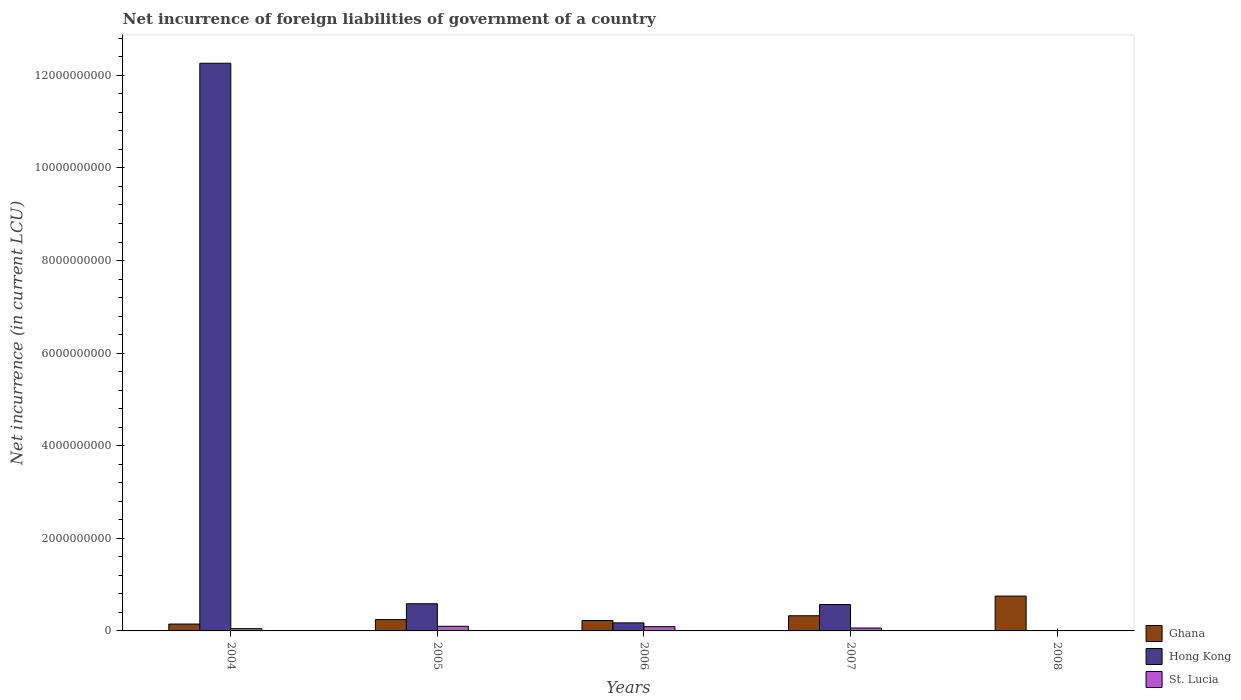Are the number of bars per tick equal to the number of legend labels?
Provide a succinct answer. No. Are the number of bars on each tick of the X-axis equal?
Provide a short and direct response. No. How many bars are there on the 4th tick from the left?
Provide a succinct answer. 3. What is the label of the 1st group of bars from the left?
Your answer should be compact. 2004. What is the net incurrence of foreign liabilities in Ghana in 2008?
Ensure brevity in your answer.  7.53e+08. Across all years, what is the maximum net incurrence of foreign liabilities in St. Lucia?
Offer a terse response. 9.99e+07. Across all years, what is the minimum net incurrence of foreign liabilities in St. Lucia?
Provide a short and direct response. 0. In which year was the net incurrence of foreign liabilities in St. Lucia maximum?
Offer a very short reply. 2005. What is the total net incurrence of foreign liabilities in Ghana in the graph?
Give a very brief answer. 1.70e+09. What is the difference between the net incurrence of foreign liabilities in Hong Kong in 2005 and that in 2006?
Keep it short and to the point. 4.13e+08. What is the difference between the net incurrence of foreign liabilities in Ghana in 2007 and the net incurrence of foreign liabilities in St. Lucia in 2005?
Provide a short and direct response. 2.27e+08. What is the average net incurrence of foreign liabilities in Ghana per year?
Your response must be concise. 3.40e+08. In the year 2006, what is the difference between the net incurrence of foreign liabilities in Hong Kong and net incurrence of foreign liabilities in St. Lucia?
Provide a short and direct response. 8.17e+07. In how many years, is the net incurrence of foreign liabilities in St. Lucia greater than 5200000000 LCU?
Keep it short and to the point. 0. What is the ratio of the net incurrence of foreign liabilities in Ghana in 2005 to that in 2007?
Your response must be concise. 0.75. Is the difference between the net incurrence of foreign liabilities in Hong Kong in 2006 and 2007 greater than the difference between the net incurrence of foreign liabilities in St. Lucia in 2006 and 2007?
Keep it short and to the point. No. What is the difference between the highest and the second highest net incurrence of foreign liabilities in St. Lucia?
Keep it short and to the point. 7.60e+06. What is the difference between the highest and the lowest net incurrence of foreign liabilities in St. Lucia?
Offer a very short reply. 9.99e+07. How many bars are there?
Make the answer very short. 13. Are all the bars in the graph horizontal?
Make the answer very short. No. Are the values on the major ticks of Y-axis written in scientific E-notation?
Make the answer very short. No. Does the graph contain any zero values?
Offer a very short reply. Yes. What is the title of the graph?
Your answer should be compact. Net incurrence of foreign liabilities of government of a country. What is the label or title of the X-axis?
Your response must be concise. Years. What is the label or title of the Y-axis?
Offer a terse response. Net incurrence (in current LCU). What is the Net incurrence (in current LCU) of Ghana in 2004?
Make the answer very short. 1.49e+08. What is the Net incurrence (in current LCU) of Hong Kong in 2004?
Offer a very short reply. 1.23e+1. What is the Net incurrence (in current LCU) in St. Lucia in 2004?
Offer a terse response. 4.89e+07. What is the Net incurrence (in current LCU) in Ghana in 2005?
Make the answer very short. 2.45e+08. What is the Net incurrence (in current LCU) in Hong Kong in 2005?
Provide a short and direct response. 5.87e+08. What is the Net incurrence (in current LCU) in St. Lucia in 2005?
Give a very brief answer. 9.99e+07. What is the Net incurrence (in current LCU) in Ghana in 2006?
Provide a succinct answer. 2.25e+08. What is the Net incurrence (in current LCU) of Hong Kong in 2006?
Make the answer very short. 1.74e+08. What is the Net incurrence (in current LCU) of St. Lucia in 2006?
Your answer should be very brief. 9.23e+07. What is the Net incurrence (in current LCU) of Ghana in 2007?
Keep it short and to the point. 3.27e+08. What is the Net incurrence (in current LCU) of Hong Kong in 2007?
Your answer should be very brief. 5.70e+08. What is the Net incurrence (in current LCU) in St. Lucia in 2007?
Your answer should be compact. 6.28e+07. What is the Net incurrence (in current LCU) of Ghana in 2008?
Offer a very short reply. 7.53e+08. Across all years, what is the maximum Net incurrence (in current LCU) in Ghana?
Offer a very short reply. 7.53e+08. Across all years, what is the maximum Net incurrence (in current LCU) in Hong Kong?
Your answer should be very brief. 1.23e+1. Across all years, what is the maximum Net incurrence (in current LCU) of St. Lucia?
Provide a short and direct response. 9.99e+07. Across all years, what is the minimum Net incurrence (in current LCU) in Ghana?
Provide a short and direct response. 1.49e+08. What is the total Net incurrence (in current LCU) in Ghana in the graph?
Provide a succinct answer. 1.70e+09. What is the total Net incurrence (in current LCU) of Hong Kong in the graph?
Your answer should be very brief. 1.36e+1. What is the total Net incurrence (in current LCU) in St. Lucia in the graph?
Offer a very short reply. 3.04e+08. What is the difference between the Net incurrence (in current LCU) in Ghana in 2004 and that in 2005?
Keep it short and to the point. -9.61e+07. What is the difference between the Net incurrence (in current LCU) in Hong Kong in 2004 and that in 2005?
Your response must be concise. 1.17e+1. What is the difference between the Net incurrence (in current LCU) in St. Lucia in 2004 and that in 2005?
Your answer should be very brief. -5.10e+07. What is the difference between the Net incurrence (in current LCU) of Ghana in 2004 and that in 2006?
Your answer should be very brief. -7.64e+07. What is the difference between the Net incurrence (in current LCU) of Hong Kong in 2004 and that in 2006?
Provide a short and direct response. 1.21e+1. What is the difference between the Net incurrence (in current LCU) in St. Lucia in 2004 and that in 2006?
Provide a short and direct response. -4.34e+07. What is the difference between the Net incurrence (in current LCU) of Ghana in 2004 and that in 2007?
Ensure brevity in your answer.  -1.79e+08. What is the difference between the Net incurrence (in current LCU) in Hong Kong in 2004 and that in 2007?
Make the answer very short. 1.17e+1. What is the difference between the Net incurrence (in current LCU) of St. Lucia in 2004 and that in 2007?
Give a very brief answer. -1.39e+07. What is the difference between the Net incurrence (in current LCU) of Ghana in 2004 and that in 2008?
Offer a very short reply. -6.04e+08. What is the difference between the Net incurrence (in current LCU) in Ghana in 2005 and that in 2006?
Offer a terse response. 1.97e+07. What is the difference between the Net incurrence (in current LCU) of Hong Kong in 2005 and that in 2006?
Offer a terse response. 4.13e+08. What is the difference between the Net incurrence (in current LCU) in St. Lucia in 2005 and that in 2006?
Your answer should be very brief. 7.60e+06. What is the difference between the Net incurrence (in current LCU) of Ghana in 2005 and that in 2007?
Keep it short and to the point. -8.27e+07. What is the difference between the Net incurrence (in current LCU) of Hong Kong in 2005 and that in 2007?
Make the answer very short. 1.70e+07. What is the difference between the Net incurrence (in current LCU) of St. Lucia in 2005 and that in 2007?
Ensure brevity in your answer.  3.71e+07. What is the difference between the Net incurrence (in current LCU) in Ghana in 2005 and that in 2008?
Your answer should be compact. -5.08e+08. What is the difference between the Net incurrence (in current LCU) in Ghana in 2006 and that in 2007?
Ensure brevity in your answer.  -1.02e+08. What is the difference between the Net incurrence (in current LCU) of Hong Kong in 2006 and that in 2007?
Your answer should be compact. -3.96e+08. What is the difference between the Net incurrence (in current LCU) of St. Lucia in 2006 and that in 2007?
Keep it short and to the point. 2.95e+07. What is the difference between the Net incurrence (in current LCU) in Ghana in 2006 and that in 2008?
Your response must be concise. -5.28e+08. What is the difference between the Net incurrence (in current LCU) of Ghana in 2007 and that in 2008?
Provide a short and direct response. -4.25e+08. What is the difference between the Net incurrence (in current LCU) of Ghana in 2004 and the Net incurrence (in current LCU) of Hong Kong in 2005?
Provide a short and direct response. -4.38e+08. What is the difference between the Net incurrence (in current LCU) of Ghana in 2004 and the Net incurrence (in current LCU) of St. Lucia in 2005?
Keep it short and to the point. 4.87e+07. What is the difference between the Net incurrence (in current LCU) in Hong Kong in 2004 and the Net incurrence (in current LCU) in St. Lucia in 2005?
Your response must be concise. 1.22e+1. What is the difference between the Net incurrence (in current LCU) in Ghana in 2004 and the Net incurrence (in current LCU) in Hong Kong in 2006?
Offer a very short reply. -2.54e+07. What is the difference between the Net incurrence (in current LCU) of Ghana in 2004 and the Net incurrence (in current LCU) of St. Lucia in 2006?
Offer a terse response. 5.63e+07. What is the difference between the Net incurrence (in current LCU) in Hong Kong in 2004 and the Net incurrence (in current LCU) in St. Lucia in 2006?
Your response must be concise. 1.22e+1. What is the difference between the Net incurrence (in current LCU) in Ghana in 2004 and the Net incurrence (in current LCU) in Hong Kong in 2007?
Keep it short and to the point. -4.21e+08. What is the difference between the Net incurrence (in current LCU) of Ghana in 2004 and the Net incurrence (in current LCU) of St. Lucia in 2007?
Your answer should be very brief. 8.58e+07. What is the difference between the Net incurrence (in current LCU) in Hong Kong in 2004 and the Net incurrence (in current LCU) in St. Lucia in 2007?
Your answer should be compact. 1.22e+1. What is the difference between the Net incurrence (in current LCU) in Ghana in 2005 and the Net incurrence (in current LCU) in Hong Kong in 2006?
Ensure brevity in your answer.  7.06e+07. What is the difference between the Net incurrence (in current LCU) of Ghana in 2005 and the Net incurrence (in current LCU) of St. Lucia in 2006?
Your response must be concise. 1.52e+08. What is the difference between the Net incurrence (in current LCU) in Hong Kong in 2005 and the Net incurrence (in current LCU) in St. Lucia in 2006?
Give a very brief answer. 4.95e+08. What is the difference between the Net incurrence (in current LCU) of Ghana in 2005 and the Net incurrence (in current LCU) of Hong Kong in 2007?
Your answer should be compact. -3.25e+08. What is the difference between the Net incurrence (in current LCU) of Ghana in 2005 and the Net incurrence (in current LCU) of St. Lucia in 2007?
Your answer should be very brief. 1.82e+08. What is the difference between the Net incurrence (in current LCU) in Hong Kong in 2005 and the Net incurrence (in current LCU) in St. Lucia in 2007?
Provide a short and direct response. 5.24e+08. What is the difference between the Net incurrence (in current LCU) in Ghana in 2006 and the Net incurrence (in current LCU) in Hong Kong in 2007?
Your answer should be compact. -3.45e+08. What is the difference between the Net incurrence (in current LCU) in Ghana in 2006 and the Net incurrence (in current LCU) in St. Lucia in 2007?
Provide a succinct answer. 1.62e+08. What is the difference between the Net incurrence (in current LCU) of Hong Kong in 2006 and the Net incurrence (in current LCU) of St. Lucia in 2007?
Offer a terse response. 1.11e+08. What is the average Net incurrence (in current LCU) in Ghana per year?
Your answer should be compact. 3.40e+08. What is the average Net incurrence (in current LCU) in Hong Kong per year?
Offer a very short reply. 2.72e+09. What is the average Net incurrence (in current LCU) of St. Lucia per year?
Your response must be concise. 6.08e+07. In the year 2004, what is the difference between the Net incurrence (in current LCU) of Ghana and Net incurrence (in current LCU) of Hong Kong?
Offer a very short reply. -1.21e+1. In the year 2004, what is the difference between the Net incurrence (in current LCU) of Ghana and Net incurrence (in current LCU) of St. Lucia?
Provide a short and direct response. 9.97e+07. In the year 2004, what is the difference between the Net incurrence (in current LCU) of Hong Kong and Net incurrence (in current LCU) of St. Lucia?
Your answer should be compact. 1.22e+1. In the year 2005, what is the difference between the Net incurrence (in current LCU) of Ghana and Net incurrence (in current LCU) of Hong Kong?
Your response must be concise. -3.42e+08. In the year 2005, what is the difference between the Net incurrence (in current LCU) in Ghana and Net incurrence (in current LCU) in St. Lucia?
Provide a succinct answer. 1.45e+08. In the year 2005, what is the difference between the Net incurrence (in current LCU) of Hong Kong and Net incurrence (in current LCU) of St. Lucia?
Your answer should be compact. 4.87e+08. In the year 2006, what is the difference between the Net incurrence (in current LCU) of Ghana and Net incurrence (in current LCU) of Hong Kong?
Your answer should be compact. 5.10e+07. In the year 2006, what is the difference between the Net incurrence (in current LCU) in Ghana and Net incurrence (in current LCU) in St. Lucia?
Give a very brief answer. 1.33e+08. In the year 2006, what is the difference between the Net incurrence (in current LCU) of Hong Kong and Net incurrence (in current LCU) of St. Lucia?
Your response must be concise. 8.17e+07. In the year 2007, what is the difference between the Net incurrence (in current LCU) of Ghana and Net incurrence (in current LCU) of Hong Kong?
Your response must be concise. -2.43e+08. In the year 2007, what is the difference between the Net incurrence (in current LCU) in Ghana and Net incurrence (in current LCU) in St. Lucia?
Offer a very short reply. 2.65e+08. In the year 2007, what is the difference between the Net incurrence (in current LCU) in Hong Kong and Net incurrence (in current LCU) in St. Lucia?
Ensure brevity in your answer.  5.07e+08. What is the ratio of the Net incurrence (in current LCU) in Ghana in 2004 to that in 2005?
Your answer should be compact. 0.61. What is the ratio of the Net incurrence (in current LCU) in Hong Kong in 2004 to that in 2005?
Ensure brevity in your answer.  20.89. What is the ratio of the Net incurrence (in current LCU) of St. Lucia in 2004 to that in 2005?
Your response must be concise. 0.49. What is the ratio of the Net incurrence (in current LCU) of Ghana in 2004 to that in 2006?
Ensure brevity in your answer.  0.66. What is the ratio of the Net incurrence (in current LCU) in Hong Kong in 2004 to that in 2006?
Offer a terse response. 70.47. What is the ratio of the Net incurrence (in current LCU) in St. Lucia in 2004 to that in 2006?
Provide a succinct answer. 0.53. What is the ratio of the Net incurrence (in current LCU) in Ghana in 2004 to that in 2007?
Your answer should be compact. 0.45. What is the ratio of the Net incurrence (in current LCU) of Hong Kong in 2004 to that in 2007?
Provide a short and direct response. 21.51. What is the ratio of the Net incurrence (in current LCU) of St. Lucia in 2004 to that in 2007?
Ensure brevity in your answer.  0.78. What is the ratio of the Net incurrence (in current LCU) in Ghana in 2004 to that in 2008?
Ensure brevity in your answer.  0.2. What is the ratio of the Net incurrence (in current LCU) in Ghana in 2005 to that in 2006?
Keep it short and to the point. 1.09. What is the ratio of the Net incurrence (in current LCU) of Hong Kong in 2005 to that in 2006?
Your answer should be very brief. 3.37. What is the ratio of the Net incurrence (in current LCU) in St. Lucia in 2005 to that in 2006?
Your answer should be very brief. 1.08. What is the ratio of the Net incurrence (in current LCU) of Ghana in 2005 to that in 2007?
Your response must be concise. 0.75. What is the ratio of the Net incurrence (in current LCU) in Hong Kong in 2005 to that in 2007?
Provide a short and direct response. 1.03. What is the ratio of the Net incurrence (in current LCU) in St. Lucia in 2005 to that in 2007?
Your answer should be very brief. 1.59. What is the ratio of the Net incurrence (in current LCU) of Ghana in 2005 to that in 2008?
Offer a very short reply. 0.33. What is the ratio of the Net incurrence (in current LCU) of Ghana in 2006 to that in 2007?
Provide a succinct answer. 0.69. What is the ratio of the Net incurrence (in current LCU) in Hong Kong in 2006 to that in 2007?
Give a very brief answer. 0.31. What is the ratio of the Net incurrence (in current LCU) in St. Lucia in 2006 to that in 2007?
Keep it short and to the point. 1.47. What is the ratio of the Net incurrence (in current LCU) in Ghana in 2006 to that in 2008?
Provide a short and direct response. 0.3. What is the ratio of the Net incurrence (in current LCU) in Ghana in 2007 to that in 2008?
Offer a very short reply. 0.43. What is the difference between the highest and the second highest Net incurrence (in current LCU) of Ghana?
Give a very brief answer. 4.25e+08. What is the difference between the highest and the second highest Net incurrence (in current LCU) in Hong Kong?
Ensure brevity in your answer.  1.17e+1. What is the difference between the highest and the second highest Net incurrence (in current LCU) of St. Lucia?
Your response must be concise. 7.60e+06. What is the difference between the highest and the lowest Net incurrence (in current LCU) of Ghana?
Your answer should be compact. 6.04e+08. What is the difference between the highest and the lowest Net incurrence (in current LCU) of Hong Kong?
Keep it short and to the point. 1.23e+1. What is the difference between the highest and the lowest Net incurrence (in current LCU) in St. Lucia?
Give a very brief answer. 9.99e+07. 